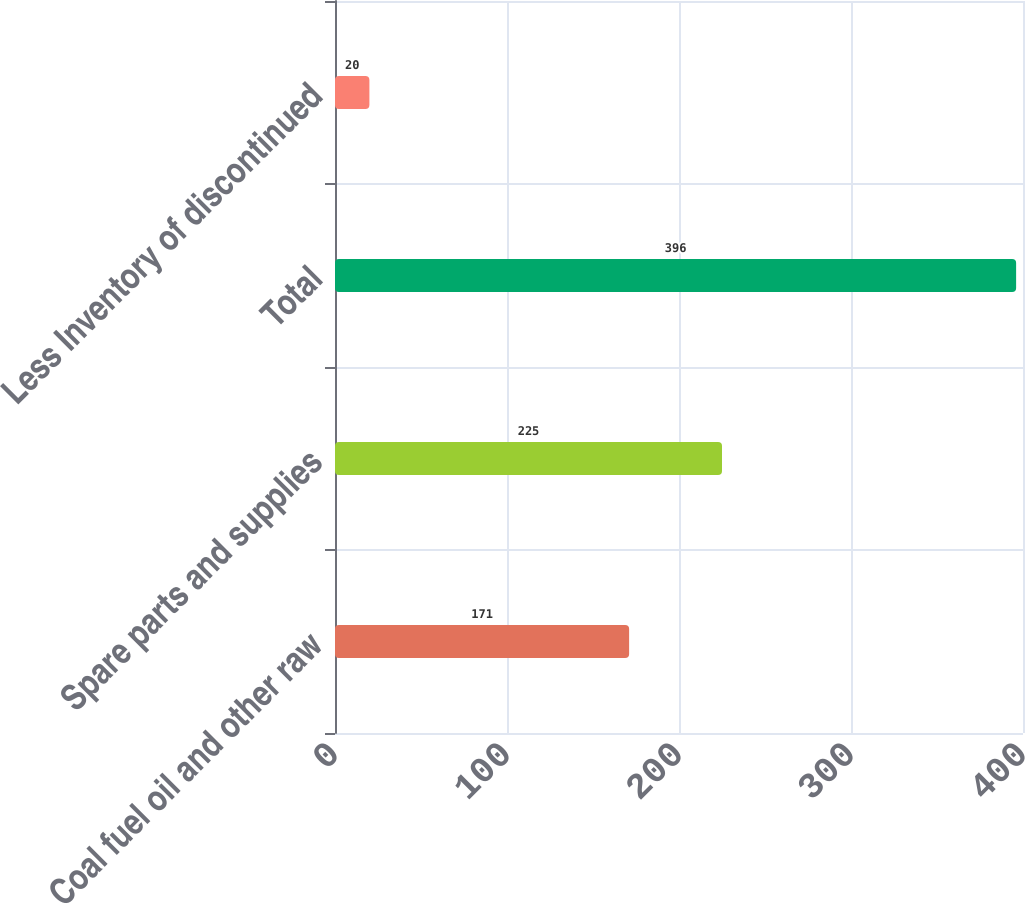<chart> <loc_0><loc_0><loc_500><loc_500><bar_chart><fcel>Coal fuel oil and other raw<fcel>Spare parts and supplies<fcel>Total<fcel>Less Inventory of discontinued<nl><fcel>171<fcel>225<fcel>396<fcel>20<nl></chart> 